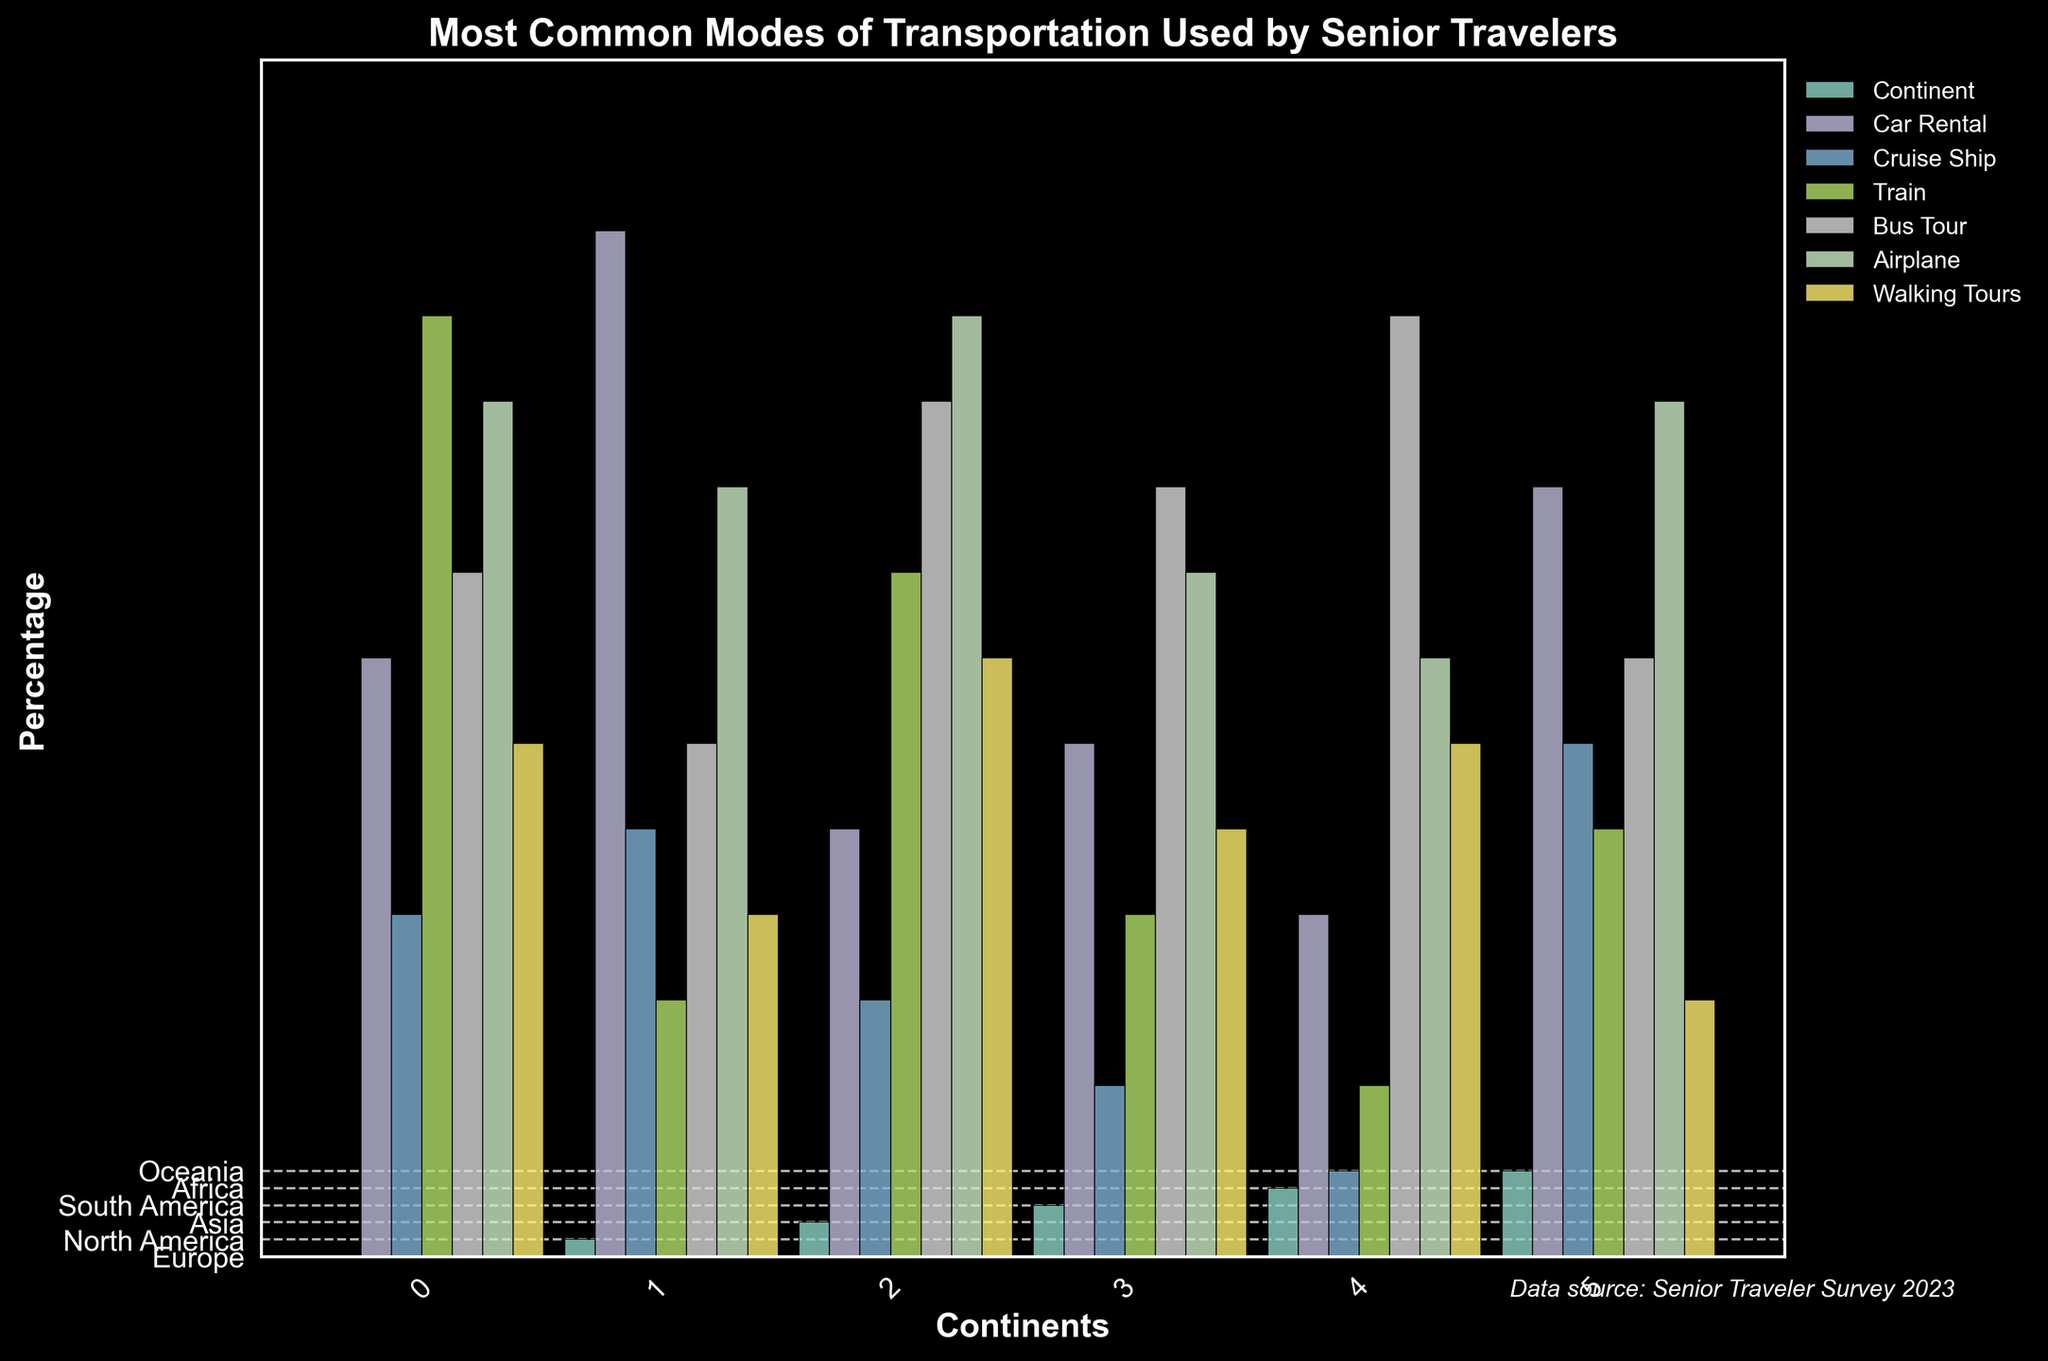What's the most common mode of transportation for senior travelers in Asia? By looking at the height of the bars in the Asia section, we can see that the Airplane bar is the tallest.
Answer: Airplane Which continent has the highest percentage of senior travelers using Cruise Ships? Looking at the height of the bars representing Cruise Ships for each continent, Oceania has the tallest bar indicating the highest percentage.
Answer: Oceania What is the difference in the percentage of senior travelers using Car Rentals between Europe and North America? The height of the Car Rental bar in Europe is 35 and in North America is 60. Subtracting these values gives 60 - 35.
Answer: 25 Which mode of transportation is least used by senior travelers in South America? In the South America section, the Cruise Ship bar has the shortest height.
Answer: Cruise Ship How many travel modes have a percentage greater than or equal to 50 in Asia? In the Asia section, the bars for Train (40), Bus Tour (50), Airplane (55), and Walking Tours (35) are visible. Only Bus Tour and Airplane are 50 or greater.
Answer: 2 Comparing Car Rentals across all continents, which continent has the lowest percentage? By checking the height of the Car Rental bars, Africa has the shortest bar at 20.
Answer: Africa Which mode of transportation has the highest variance in usage percentages across continents? To find the highest variance, we need to observe which mode has the most spread out bar heights. Here, Cruise Ship has noticeable differences like 5 in Africa to 30 in Oceania.
Answer: Cruise Ship Is Walking Tours more popular in Asia or Oceania? Comparing the height of Walking Tours bars in Asia (35) and Oceania (15), Asia is higher.
Answer: Asia What's the total percentage of senior travelers using Buses in Europe and Africa combined? The bar for Bus Tours is 40 in Europe and 55 in Africa. Adding these values gives 40 + 55.
Answer: 95 Which continent has the second highest percentage for Train usage? The heights of Train usage bars need to be compared: Europe (55), North America (15), Asia (40), South America (20), Africa (10), Oceania (25). Asia has the second highest at 40.
Answer: Asia 